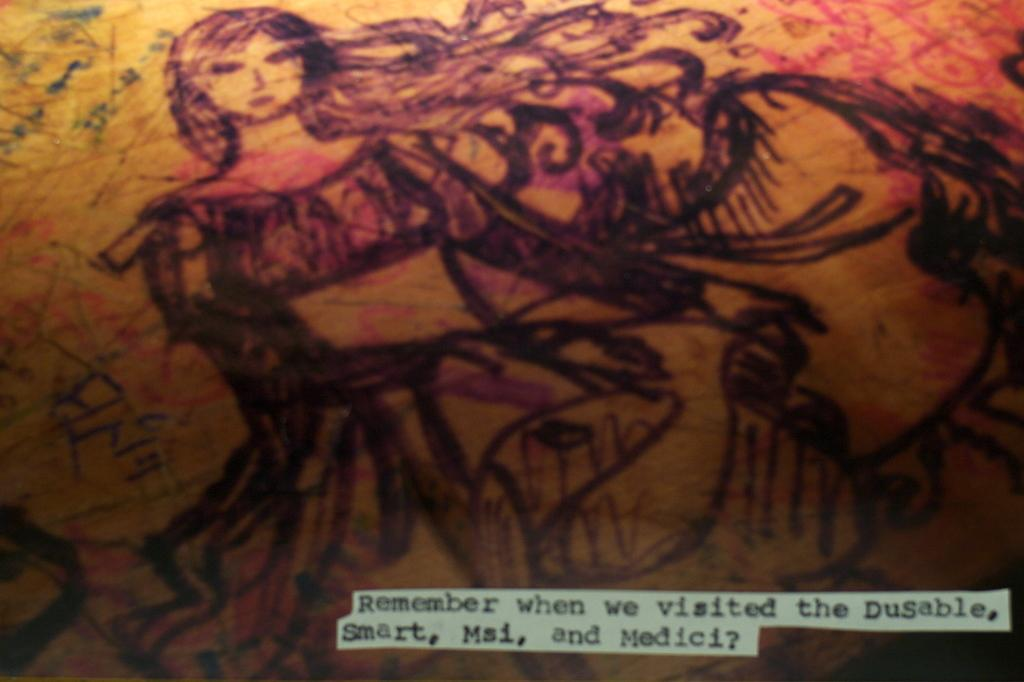What is the main subject of the image? There is a depiction of a woman in the image. Can you describe any additional elements in the image? There is text at the bottom of the image. What type of sock is the woman wearing in the image? There is no sock visible in the image, as it only depicts a woman and text at the bottom. 